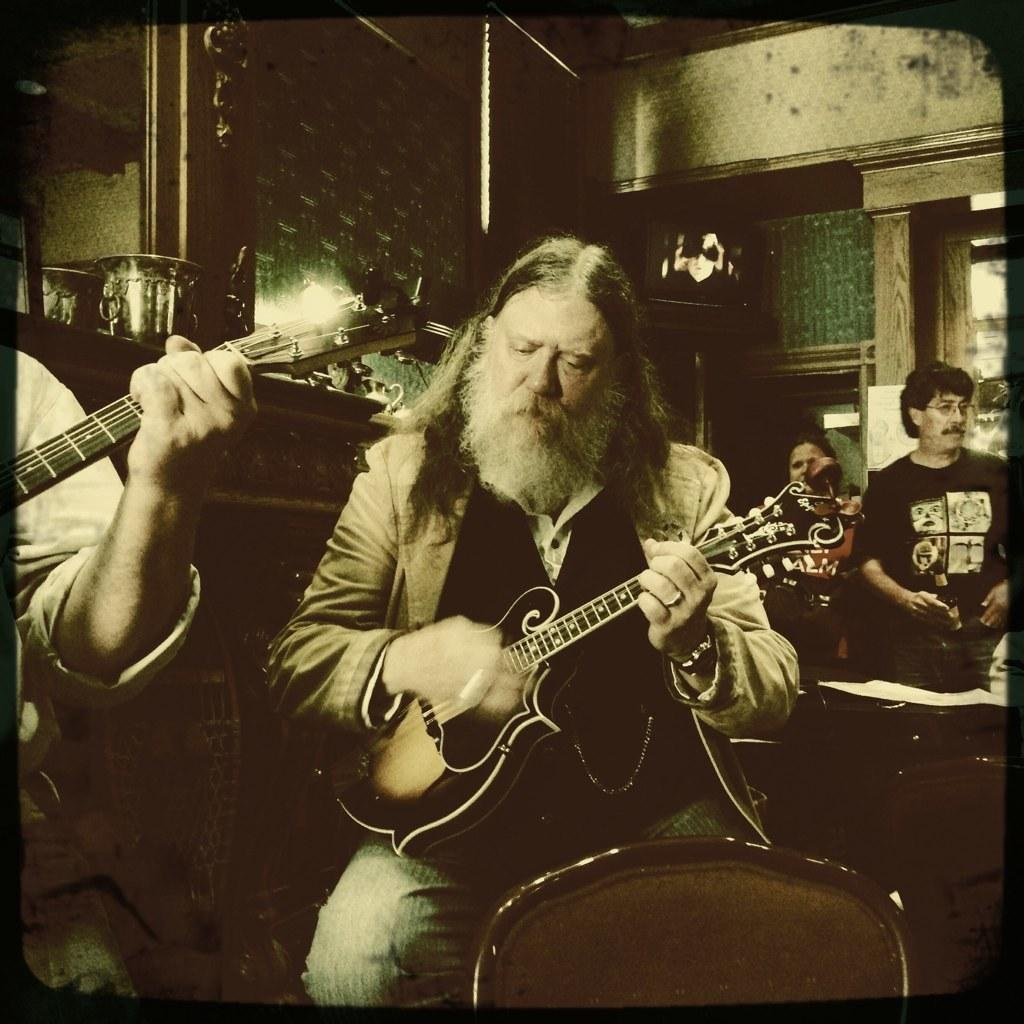What is the main subject of the image? There is a man in the image. What is the man doing in the image? The man is playing the violin with his hand. Can you describe the background of the image? There are people standing in the background of the image. What is visible at the top of the image? There is a wall visible at the top of the image. What type of tooth is visible in the image? There is no tooth visible in the image. How many nails can be seen in the image? There are no nails visible in the image. 